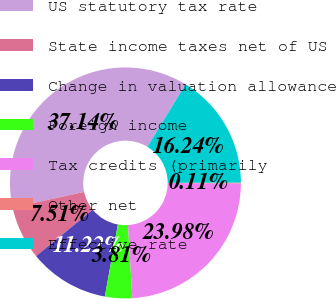Convert chart. <chart><loc_0><loc_0><loc_500><loc_500><pie_chart><fcel>US statutory tax rate<fcel>State income taxes net of US<fcel>Change in valuation allowance<fcel>Foreign income<fcel>Tax credits (primarily<fcel>Other net<fcel>Effective rate<nl><fcel>37.14%<fcel>7.51%<fcel>11.22%<fcel>3.81%<fcel>23.98%<fcel>0.11%<fcel>16.24%<nl></chart> 